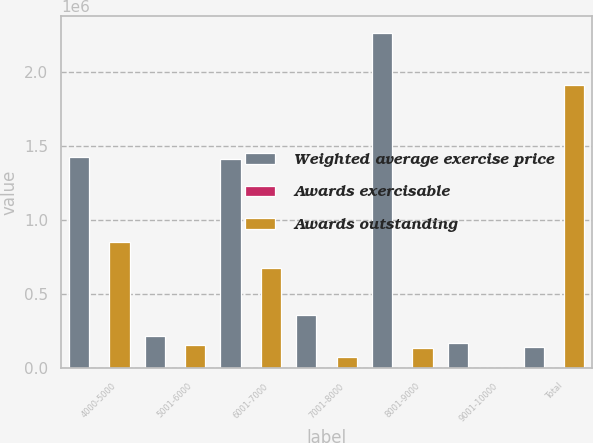<chart> <loc_0><loc_0><loc_500><loc_500><stacked_bar_chart><ecel><fcel>4000-5000<fcel>5001-6000<fcel>6001-7000<fcel>7001-8000<fcel>8001-9000<fcel>9001-10000<fcel>Total<nl><fcel>Weighted average exercise price<fcel>1.43084e+06<fcel>219443<fcel>1.41439e+06<fcel>361353<fcel>2.26422e+06<fcel>170000<fcel>147873<nl><fcel>Awards exercisable<fcel>46.07<fcel>54.1<fcel>64.44<fcel>74.38<fcel>85.08<fcel>97.08<fcel>68.74<nl><fcel>Awards outstanding<fcel>856483<fcel>159157<fcel>680444<fcel>75218<fcel>136589<fcel>937<fcel>1.91173e+06<nl></chart> 